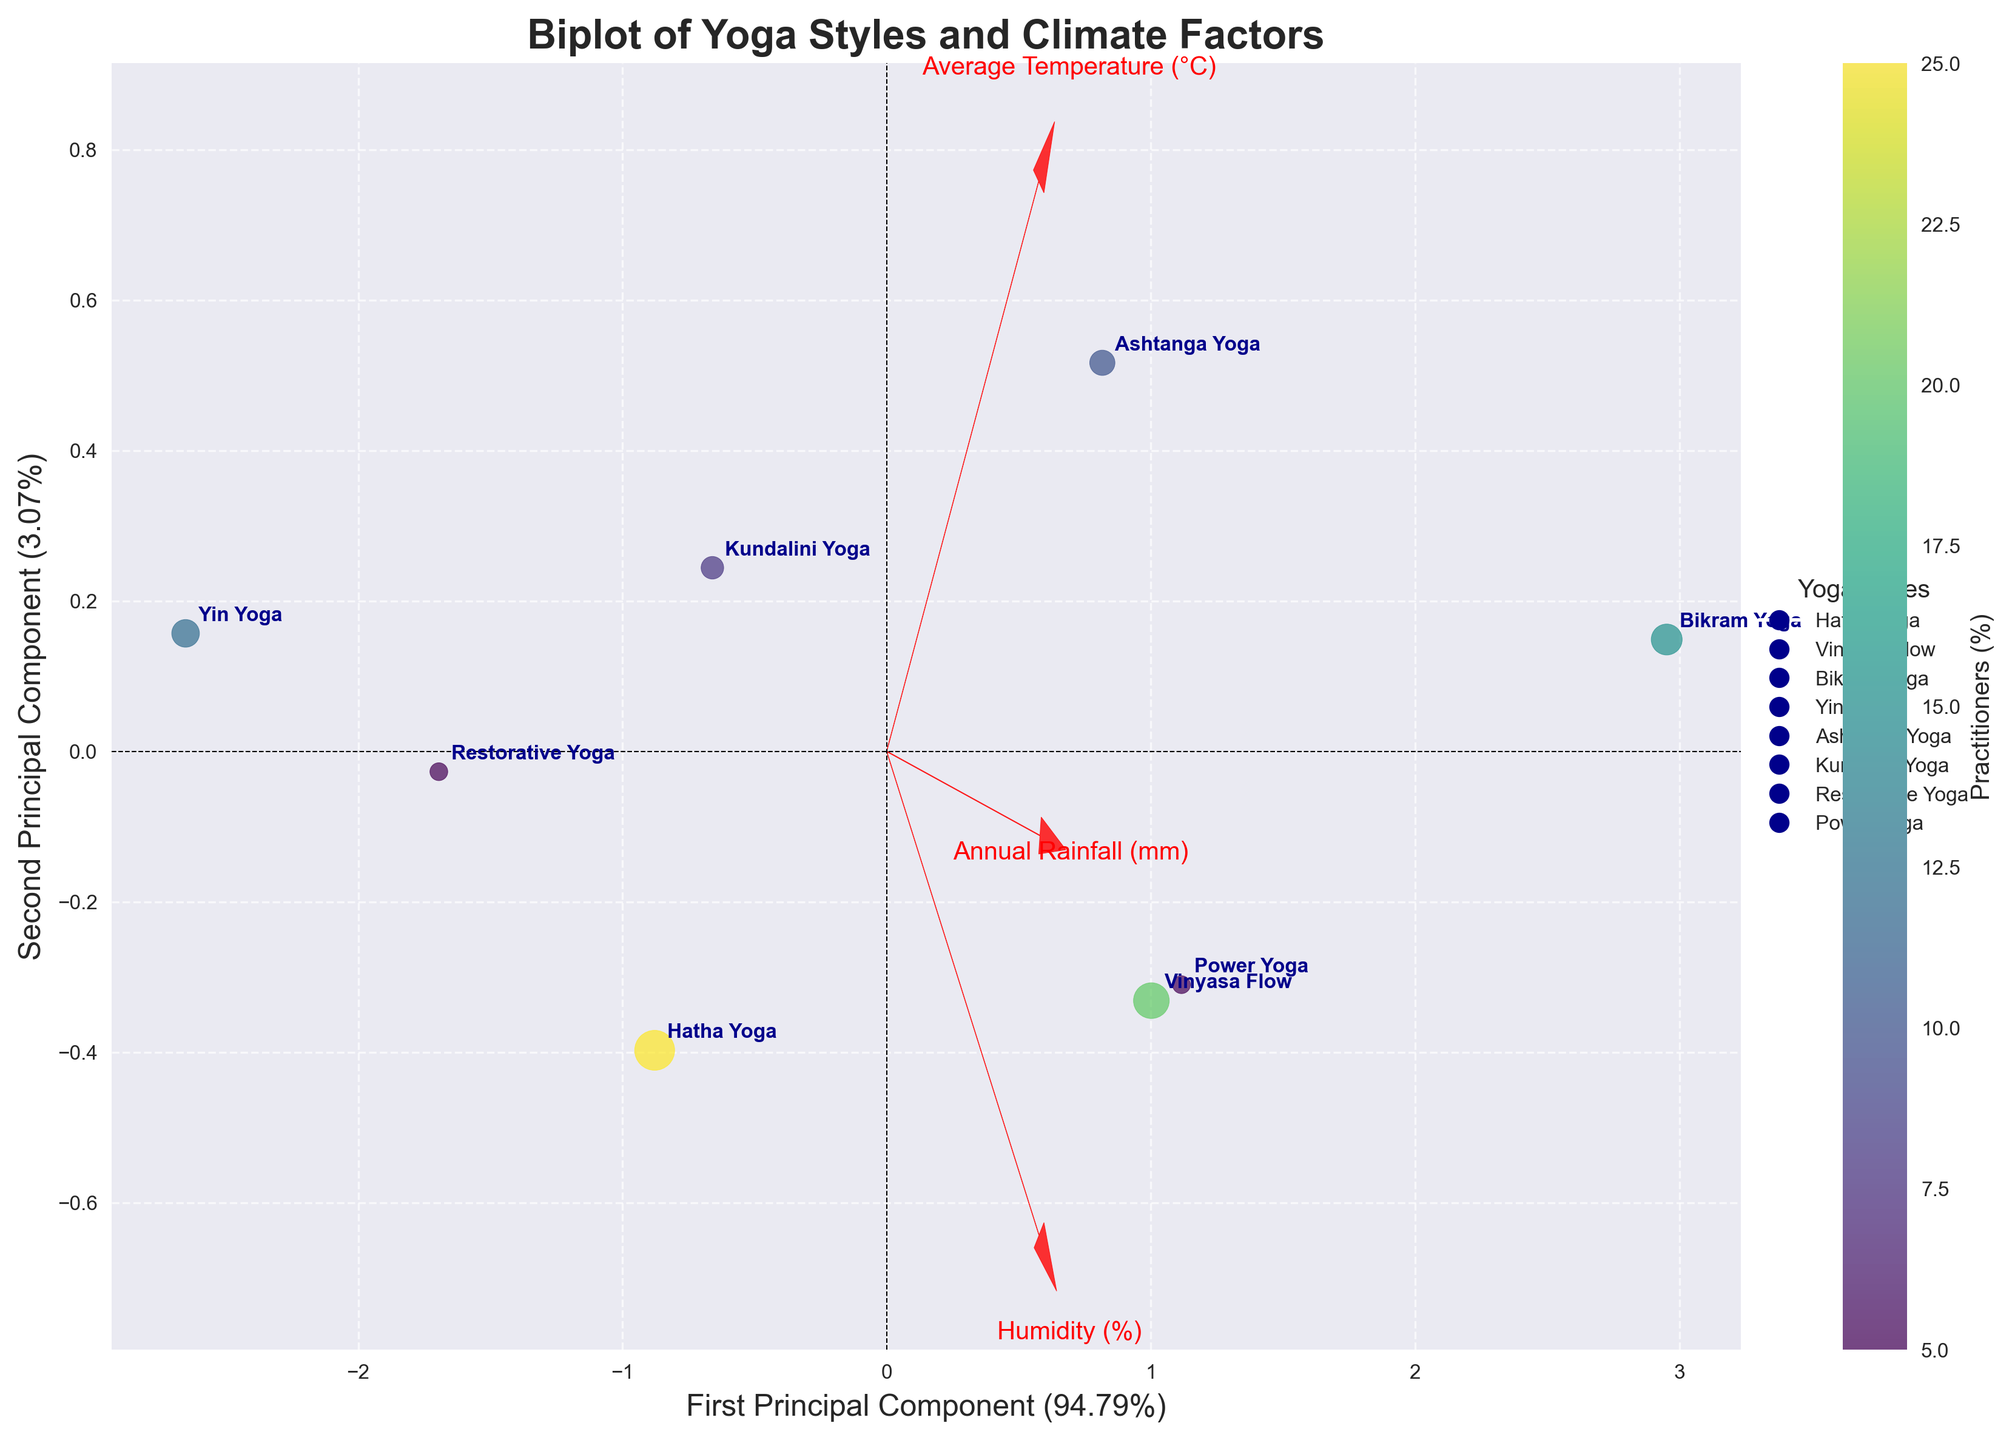What's the title of the figure? The title of a figure is usually displayed at the top, summarizing the main topic. In this case, it's clearly visible at the top of the plot.
Answer: Biplot of Yoga Styles and Climate Factors How many yoga styles are represented in the figure? The number of yoga styles can be counted by looking at the labels annotated on the data points in the plot. Each data point represents a different yoga style.
Answer: Eight Which yoga style has the highest percentage of practitioners? The size of the data points in the scatter plot indicates the percentage of practitioners. The largest data point will represent the yoga style with the highest percentage.
Answer: Hatha Yoga What are the axes labels in the biplot, and what do they represent? The axes labels can be read directly from the plot. The horizontal axis is labeled with the percentage explained by the first principal component, and the vertical axis with the percentage explained by the second principal component.
Answer: First Principal Component and Second Principal Component Which yoga style is most associated with high average temperatures and high humidity? Look for the direction and length of the vectors labeled 'Average Temperature (°C)' and 'Humidity (%)'. The yoga style data points closest to the tips of these vectors indicate a high association.
Answer: Bikram Yoga Which feature is the primary component contributing to the spread along the first principal component? The vector that points most directly along the horizontal axis (first principal component) indicates the feature contributing most to this component's spread.
Answer: Average Temperature (°C) Is there a noticeable clustering of yoga styles based on annual rainfall? Observe the positioning of data points concerning the 'Annual Rainfall (mm)' vector. If the styles are spread along this vector, it indicates significance, otherwise not.
Answer: No noticeable clustering Between Yin Yoga and Power Yoga, which one is associated with lower humidity? Compare where the data points labeled 'Yin Yoga' and 'Power Yoga' are in relation to the 'Humidity (%)' vector. The one further from the vector tip is associated with lower humidity.
Answer: Yin Yoga Which yoga style is positioned closest to the origin of the biplot? The data point closest to the intersection of the two axes represents the yoga style closest to the origin.
Answer: Restorative Yoga How do average temperature and annual rainfall correlate among the yoga styles in the plot? Examine the direction and closeness of the vectors 'Average Temperature (°C)' and 'Annual Rainfall (mm)'. The closer and more parallel they are, the higher the correlation.
Answer: Positive correlation 